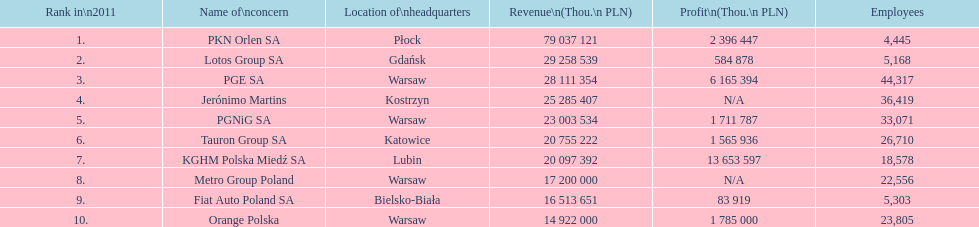What businesses are mentioned? PKN Orlen SA, Lotos Group SA, PGE SA, Jerónimo Martins, PGNiG SA, Tauron Group SA, KGHM Polska Miedź SA, Metro Group Poland, Fiat Auto Poland SA, Orange Polska. What are the business's incomes? 79 037 121, 29 258 539, 28 111 354, 25 285 407, 23 003 534, 20 755 222, 20 097 392, 17 200 000, 16 513 651, 14 922 000. Which business has the largest income? PKN Orlen SA. Help me parse the entirety of this table. {'header': ['Rank in\\n2011', 'Name of\\nconcern', 'Location of\\nheadquarters', 'Revenue\\n(Thou.\\n\xa0PLN)', 'Profit\\n(Thou.\\n\xa0PLN)', 'Employees'], 'rows': [['1.', 'PKN Orlen SA', 'Płock', '79 037 121', '2 396 447', '4,445'], ['2.', 'Lotos Group SA', 'Gdańsk', '29 258 539', '584 878', '5,168'], ['3.', 'PGE SA', 'Warsaw', '28 111 354', '6 165 394', '44,317'], ['4.', 'Jerónimo Martins', 'Kostrzyn', '25 285 407', 'N/A', '36,419'], ['5.', 'PGNiG SA', 'Warsaw', '23 003 534', '1 711 787', '33,071'], ['6.', 'Tauron Group SA', 'Katowice', '20 755 222', '1 565 936', '26,710'], ['7.', 'KGHM Polska Miedź SA', 'Lubin', '20 097 392', '13 653 597', '18,578'], ['8.', 'Metro Group Poland', 'Warsaw', '17 200 000', 'N/A', '22,556'], ['9.', 'Fiat Auto Poland SA', 'Bielsko-Biała', '16 513 651', '83 919', '5,303'], ['10.', 'Orange Polska', 'Warsaw', '14 922 000', '1 785 000', '23,805']]} 